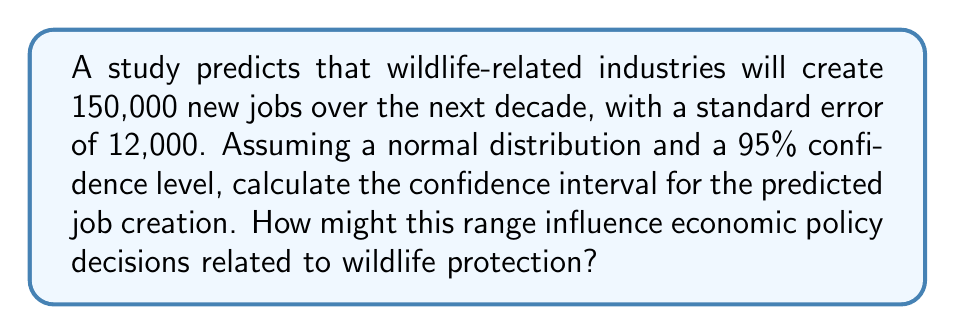What is the answer to this math problem? To calculate the confidence interval, we'll follow these steps:

1) The formula for a 95% confidence interval is:

   $$\text{Point Estimate} \pm (z_{critical} \times \text{Standard Error})$$

2) For a 95% confidence level, $z_{critical} = 1.96$

3) We're given:
   - Point Estimate (predicted job creation) = 150,000
   - Standard Error = 12,000

4) Let's plug these into our formula:

   $$150,000 \pm (1.96 \times 12,000)$$

5) Simplify:
   $$150,000 \pm 23,520$$

6) Calculate the lower and upper bounds:
   - Lower bound: $150,000 - 23,520 = 126,480$
   - Upper bound: $150,000 + 23,520 = 173,520$

7) Therefore, we can say with 95% confidence that the number of new jobs created in wildlife-related industries over the next decade will be between 126,480 and 173,520.

This range could significantly influence economic policy decisions. The lower bound of about 126,000 new jobs might still justify some wildlife protection measures, while the upper bound of about 174,000 new jobs could encourage more extensive protection policies. Policymakers might use this range to balance wildlife protection with other economic priorities, possibly favoring policies that protect wildlife while also promoting job growth in related industries.
Answer: 95% CI: (126,480, 173,520) new jobs 